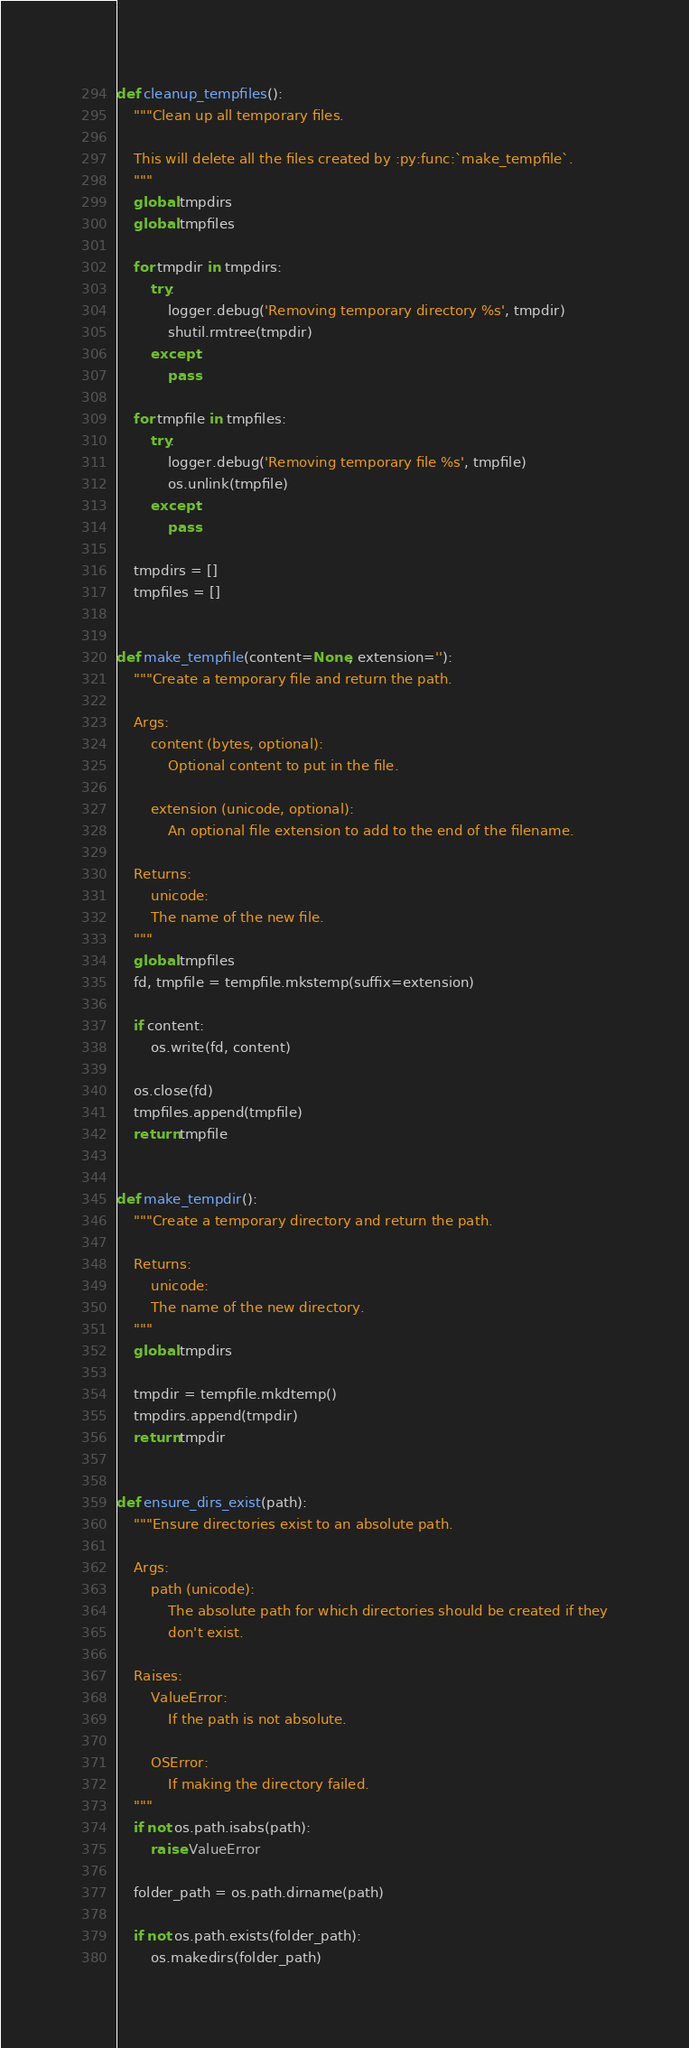<code> <loc_0><loc_0><loc_500><loc_500><_Python_>def cleanup_tempfiles():
    """Clean up all temporary files.

    This will delete all the files created by :py:func:`make_tempfile`.
    """
    global tmpdirs
    global tmpfiles

    for tmpdir in tmpdirs:
        try:
            logger.debug('Removing temporary directory %s', tmpdir)
            shutil.rmtree(tmpdir)
        except:
            pass

    for tmpfile in tmpfiles:
        try:
            logger.debug('Removing temporary file %s', tmpfile)
            os.unlink(tmpfile)
        except:
            pass

    tmpdirs = []
    tmpfiles = []


def make_tempfile(content=None, extension=''):
    """Create a temporary file and return the path.

    Args:
        content (bytes, optional):
            Optional content to put in the file.

        extension (unicode, optional):
            An optional file extension to add to the end of the filename.

    Returns:
        unicode:
        The name of the new file.
    """
    global tmpfiles
    fd, tmpfile = tempfile.mkstemp(suffix=extension)

    if content:
        os.write(fd, content)

    os.close(fd)
    tmpfiles.append(tmpfile)
    return tmpfile


def make_tempdir():
    """Create a temporary directory and return the path.

    Returns:
        unicode:
        The name of the new directory.
    """
    global tmpdirs

    tmpdir = tempfile.mkdtemp()
    tmpdirs.append(tmpdir)
    return tmpdir


def ensure_dirs_exist(path):
    """Ensure directories exist to an absolute path.

    Args:
        path (unicode):
            The absolute path for which directories should be created if they
            don't exist.

    Raises:
        ValueError:
            If the path is not absolute.

        OSError:
            If making the directory failed.
    """
    if not os.path.isabs(path):
        raise ValueError

    folder_path = os.path.dirname(path)

    if not os.path.exists(folder_path):
        os.makedirs(folder_path)
</code> 